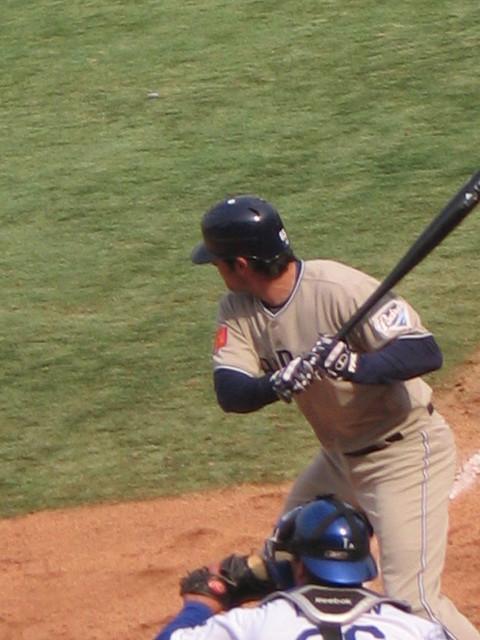What action is the man wearing blue hat doing?
Make your selection and explain in format: 'Answer: answer
Rationale: rationale.'
Options: Crouching, sitting, standing, kneeling. Answer: crouching.
Rationale: He is bent over so he can catch the ball if it goes to him. Which hand is dominant in the batter shown?
Pick the correct solution from the four options below to address the question.
Options: Right, left, neither, ambidextrous. Left. 